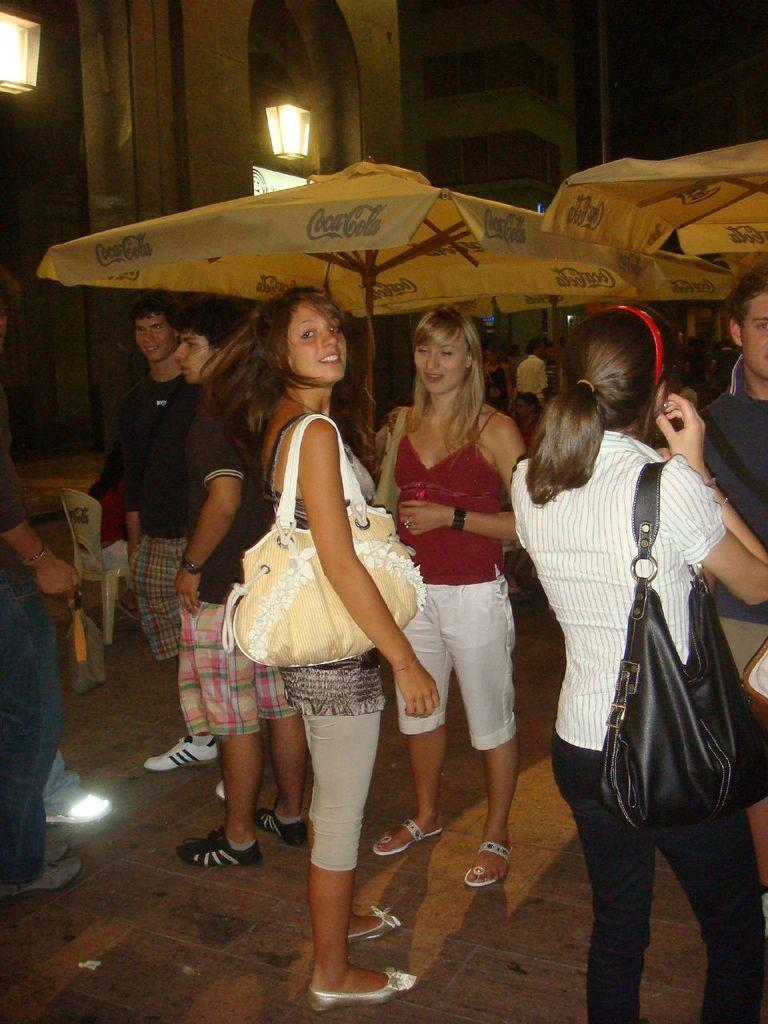How many people are in the group in the image? There is a group of people in the image, but the exact number is not specified. What are the people in the group doing? The people in the group are standing. What are some women in the group wearing? Some women in the group are wearing bags. What can be seen in the background of the image? In the background of the image, there are tents, lights, and buildings. Where is the blade located in the image? There is no blade present in the image. What type of bushes can be seen in the image? There are no bushes visible in the image. 